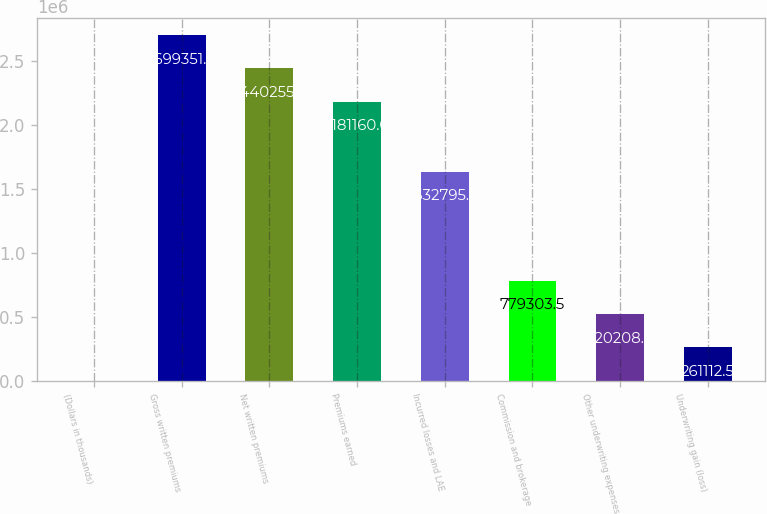<chart> <loc_0><loc_0><loc_500><loc_500><bar_chart><fcel>(Dollars in thousands)<fcel>Gross written premiums<fcel>Net written premiums<fcel>Premiums earned<fcel>Incurred losses and LAE<fcel>Commission and brokerage<fcel>Other underwriting expenses<fcel>Underwriting gain (loss)<nl><fcel>2017<fcel>2.69935e+06<fcel>2.44026e+06<fcel>2.18116e+06<fcel>1.6328e+06<fcel>779304<fcel>520208<fcel>261112<nl></chart> 